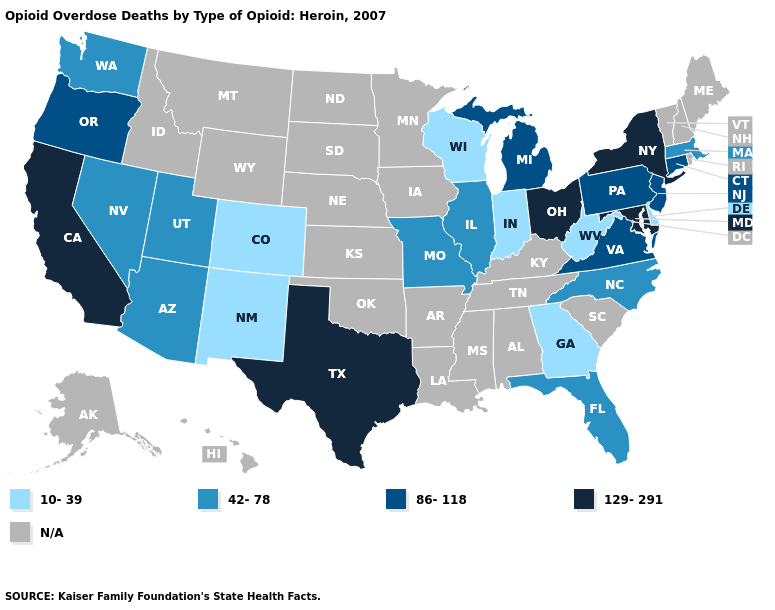Name the states that have a value in the range 42-78?
Give a very brief answer. Arizona, Florida, Illinois, Massachusetts, Missouri, Nevada, North Carolina, Utah, Washington. Does Massachusetts have the highest value in the Northeast?
Be succinct. No. What is the highest value in the USA?
Write a very short answer. 129-291. What is the value of California?
Short answer required. 129-291. Name the states that have a value in the range 129-291?
Be succinct. California, Maryland, New York, Ohio, Texas. Does Missouri have the lowest value in the USA?
Keep it brief. No. What is the value of Michigan?
Quick response, please. 86-118. What is the value of New Hampshire?
Give a very brief answer. N/A. What is the value of Virginia?
Quick response, please. 86-118. Is the legend a continuous bar?
Answer briefly. No. What is the value of Tennessee?
Write a very short answer. N/A. What is the value of California?
Answer briefly. 129-291. What is the value of Florida?
Be succinct. 42-78. Name the states that have a value in the range 10-39?
Short answer required. Colorado, Delaware, Georgia, Indiana, New Mexico, West Virginia, Wisconsin. 